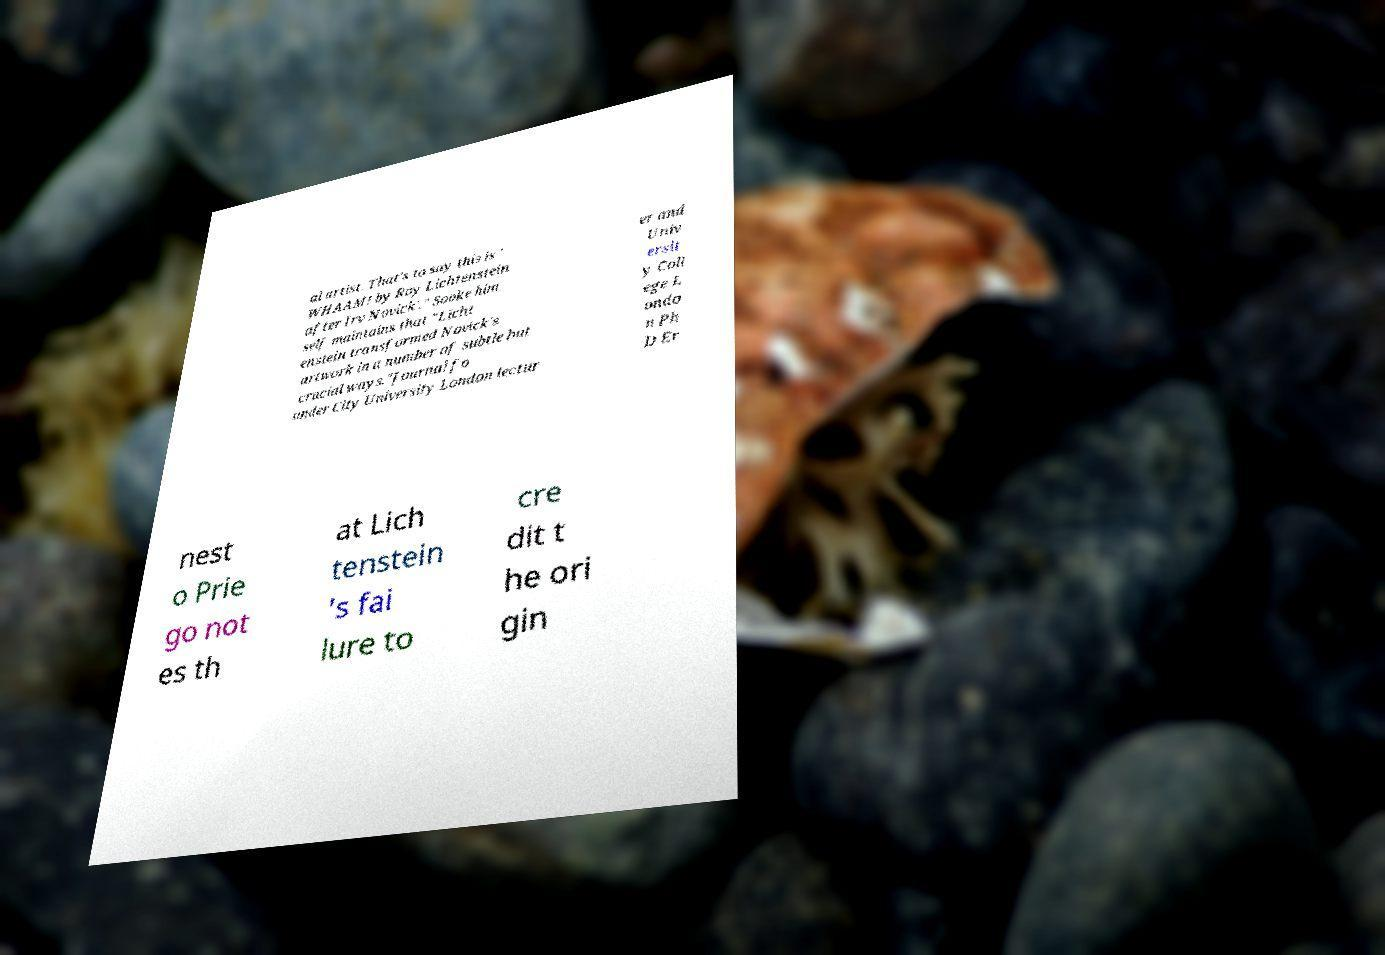I need the written content from this picture converted into text. Can you do that? al artist. That's to say this is ' WHAAM! by Roy Lichtenstein after Irv Novick'." Sooke him self maintains that "Licht enstein transformed Novick's artwork in a number of subtle but crucial ways."Journal fo under City University London lectur er and Univ ersit y Coll ege L ondo n Ph D Er nest o Prie go not es th at Lich tenstein 's fai lure to cre dit t he ori gin 